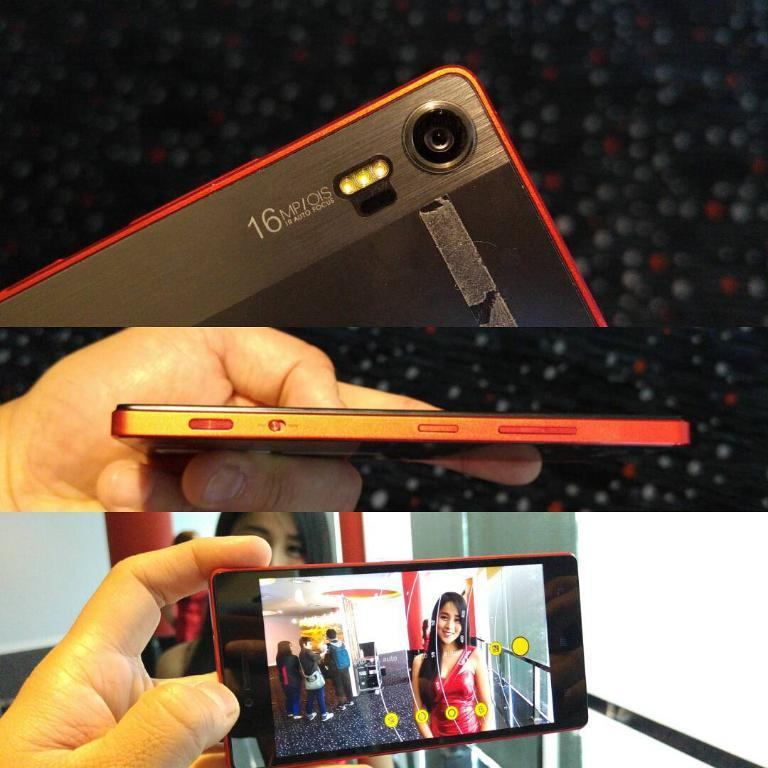<image>
Create a compact narrative representing the image presented. A 16 MP OIS cell phone with Auto Focus. 